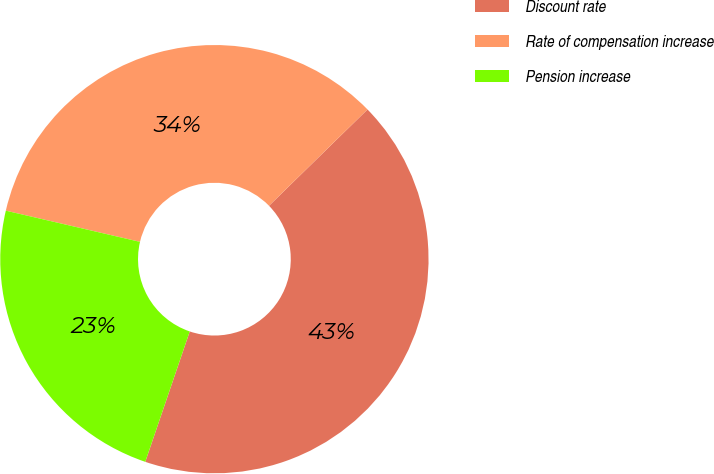Convert chart to OTSL. <chart><loc_0><loc_0><loc_500><loc_500><pie_chart><fcel>Discount rate<fcel>Rate of compensation increase<fcel>Pension increase<nl><fcel>42.55%<fcel>34.04%<fcel>23.4%<nl></chart> 